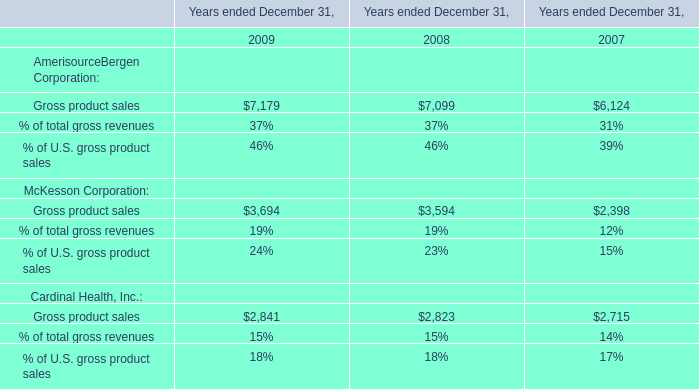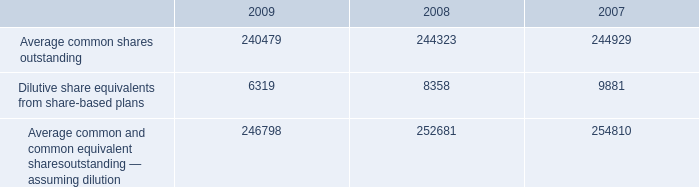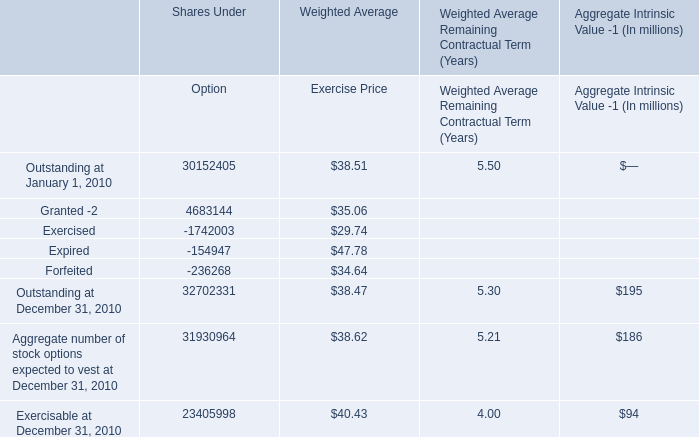What's the average of Forfeited of Shares Under Option, and Gross product sales of Years ended December 31, 2008 ? 
Computations: ((236268.0 + 7099.0) / 2)
Answer: 121683.5. 